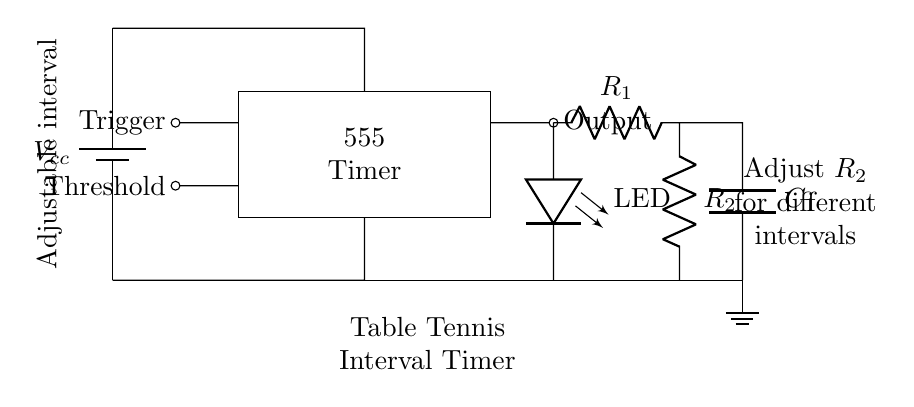What is the main component used for timing in this circuit? The main component for timing in this circuit is the 555 Timer, which is specifically designed to provide accurate timing intervals based on the configuration of resistors and capacitors connected to it.
Answer: 555 Timer How can the output be adjusted for different intervals? The output interval of the timer can be adjusted by changing the value of resistor R2. When R2's resistance is altered, it affects the charging and discharging time of the capacitor C1, which consequently changes the timing interval of the 555 Timer.
Answer: Adjust R2 What does the LED indicate in this circuit? The LED in this circuit serves as a visual indicator that shows when the output from the 555 Timer is active. It lights up when the timer's output goes high, signaling the end of a time interval.
Answer: Output status What is the role of the capacitor in this timer circuit? The capacitor C1 in this timer circuit works as an energy storage device. During each timing cycle, it charges and discharges to help establish the time intervals. The charge and discharge rates directly affect the duration of the output signal.
Answer: Energy storage Which component provides the power supply in this circuit? The power supply in this circuit is provided by the battery, denoted as Vcc, which supplies the necessary voltage for the entire circuit operation, including the timer and LED.
Answer: Battery How many resistors are present in the circuit? There are two resistors in this circuit, R1 and R2, which are essential in setting the timing intervals for the 555 Timer by controlling the charge and discharge paths of the capacitor C1.
Answer: Two What does the label "Adjustable interval" signify? The label "Adjustable interval" indicates that the timing duration can be changed or configured by the user through the component settings, particularly by adjusting the resistance of R2, to suit different training needs in table tennis.
Answer: User-configurable 